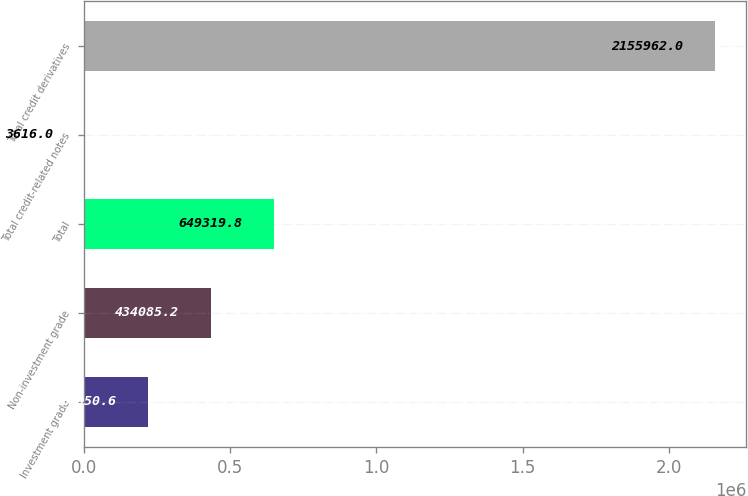Convert chart to OTSL. <chart><loc_0><loc_0><loc_500><loc_500><bar_chart><fcel>Investment grade<fcel>Non-investment grade<fcel>Total<fcel>Total credit-related notes<fcel>Total credit derivatives<nl><fcel>218851<fcel>434085<fcel>649320<fcel>3616<fcel>2.15596e+06<nl></chart> 